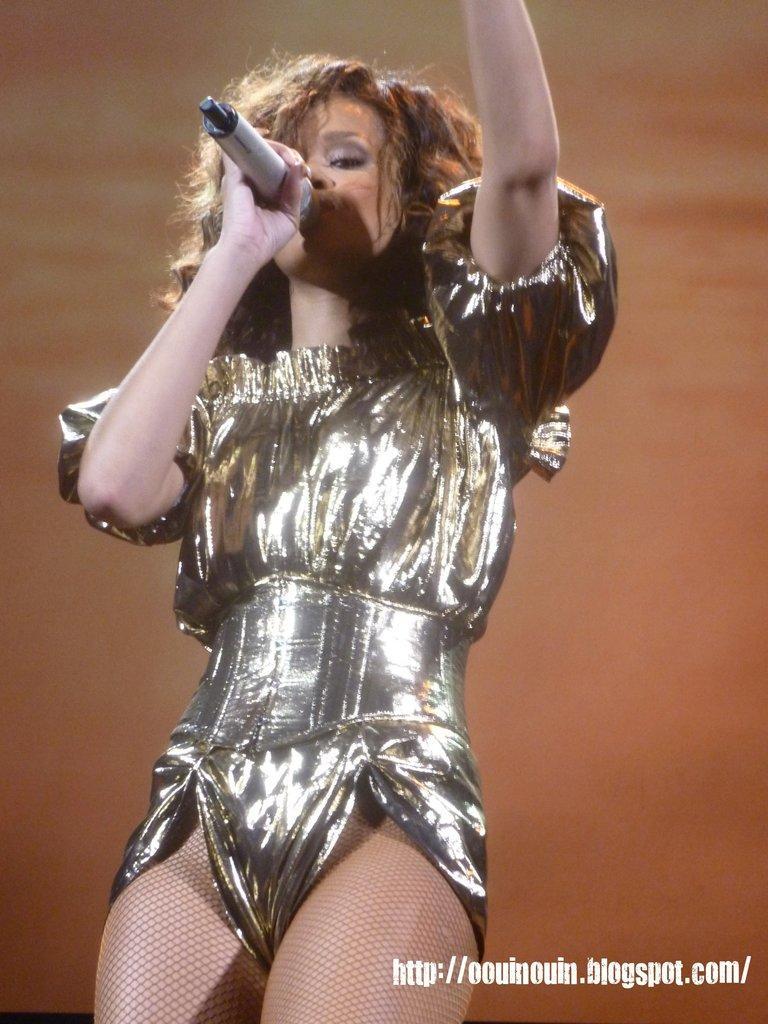Describe this image in one or two sentences. In this image I can see a woman is holding a mike in hand and a text. The background is brown in color. This image is taken may be on the stage. 